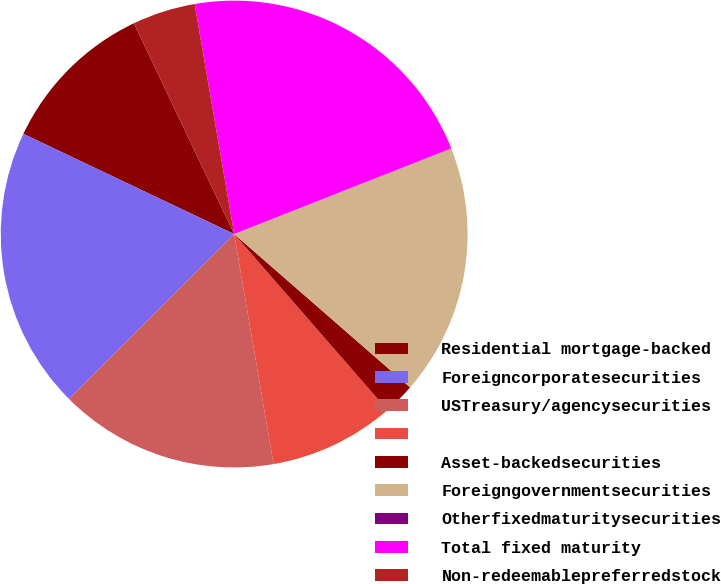<chart> <loc_0><loc_0><loc_500><loc_500><pie_chart><fcel>Residential mortgage-backed<fcel>Foreigncorporatesecurities<fcel>USTreasury/agencysecurities<fcel>Unnamed: 3<fcel>Asset-backedsecurities<fcel>Foreigngovernmentsecurities<fcel>Otherfixedmaturitysecurities<fcel>Total fixed maturity<fcel>Non-redeemablepreferredstock<nl><fcel>10.87%<fcel>19.55%<fcel>15.21%<fcel>8.7%<fcel>2.19%<fcel>17.38%<fcel>0.02%<fcel>21.72%<fcel>4.36%<nl></chart> 